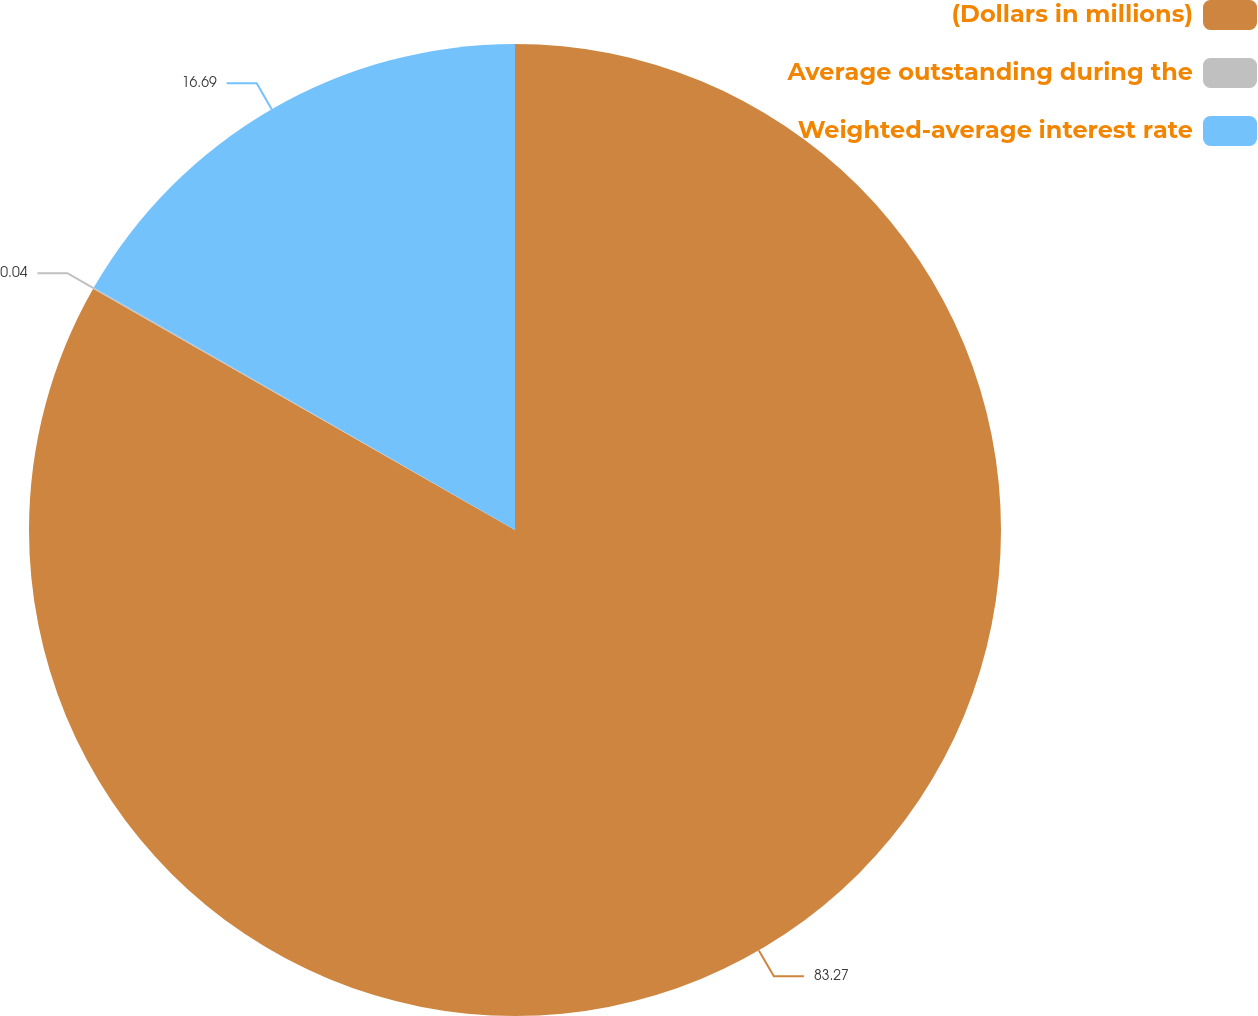<chart> <loc_0><loc_0><loc_500><loc_500><pie_chart><fcel>(Dollars in millions)<fcel>Average outstanding during the<fcel>Weighted-average interest rate<nl><fcel>83.27%<fcel>0.04%<fcel>16.69%<nl></chart> 